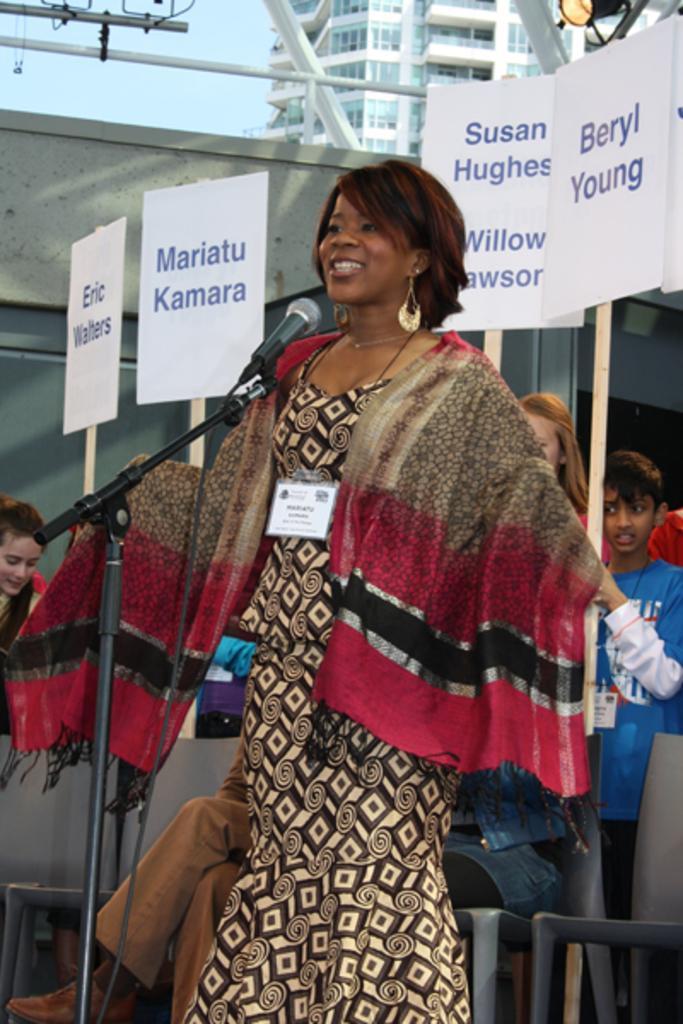In one or two sentences, can you explain what this image depicts? In this picture there is a woman who is wearing earring, scarf and dress. She is smiling, she is standing near to the mic. Behind her there is a man who is sitting on the chair. At the back we can see many peoples were holding the boards. At the top i can see the building. In the top left there is a sky. 